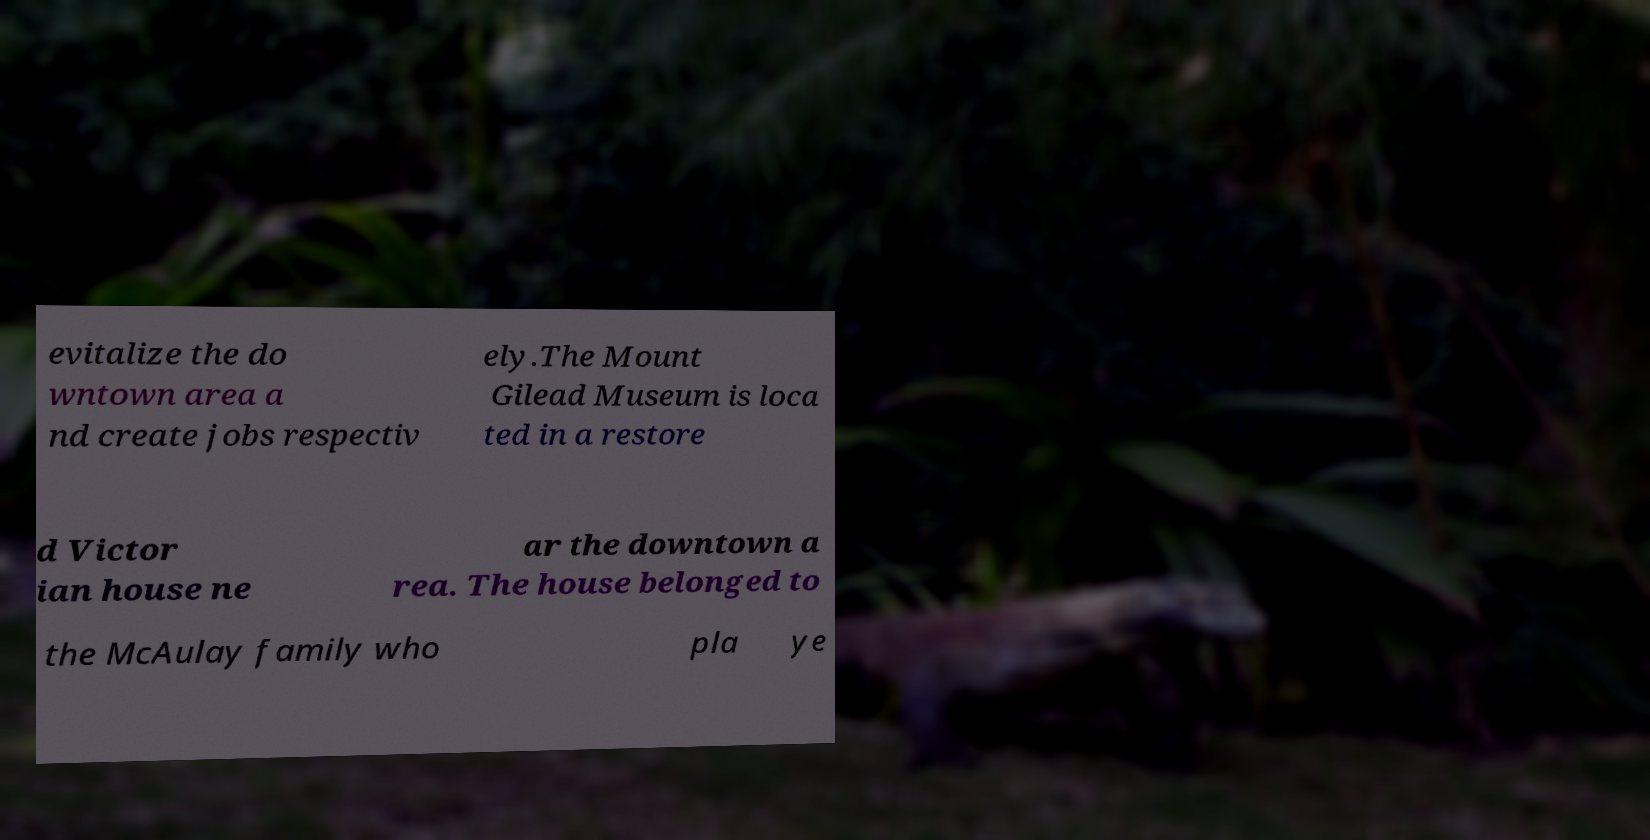Could you assist in decoding the text presented in this image and type it out clearly? evitalize the do wntown area a nd create jobs respectiv ely.The Mount Gilead Museum is loca ted in a restore d Victor ian house ne ar the downtown a rea. The house belonged to the McAulay family who pla ye 